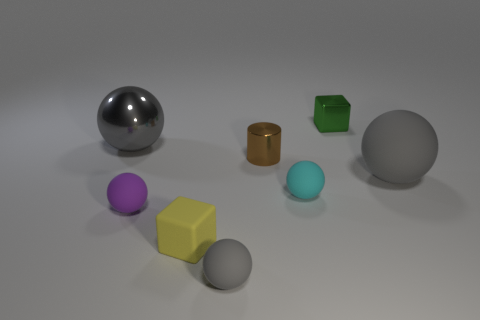There is a large object that is the same color as the large matte ball; what shape is it?
Your answer should be very brief. Sphere. There is a large matte thing; is it the same color as the big metal object that is on the left side of the small green shiny cube?
Offer a terse response. Yes. Are the tiny cyan thing and the big gray thing that is to the left of the tiny green thing made of the same material?
Provide a succinct answer. No. There is another matte thing that is the same color as the big matte thing; what size is it?
Ensure brevity in your answer.  Small. Is there a big gray cylinder made of the same material as the purple ball?
Your answer should be very brief. No. What number of objects are either spheres that are in front of the brown thing or spheres on the left side of the tiny green metallic object?
Keep it short and to the point. 5. There is a tiny cyan thing; is its shape the same as the large thing on the right side of the small metallic cylinder?
Offer a very short reply. Yes. What number of other things are there of the same shape as the green thing?
Keep it short and to the point. 1. What number of objects are big purple metal blocks or balls?
Your answer should be very brief. 5. Does the big matte sphere have the same color as the large metallic ball?
Offer a very short reply. Yes. 